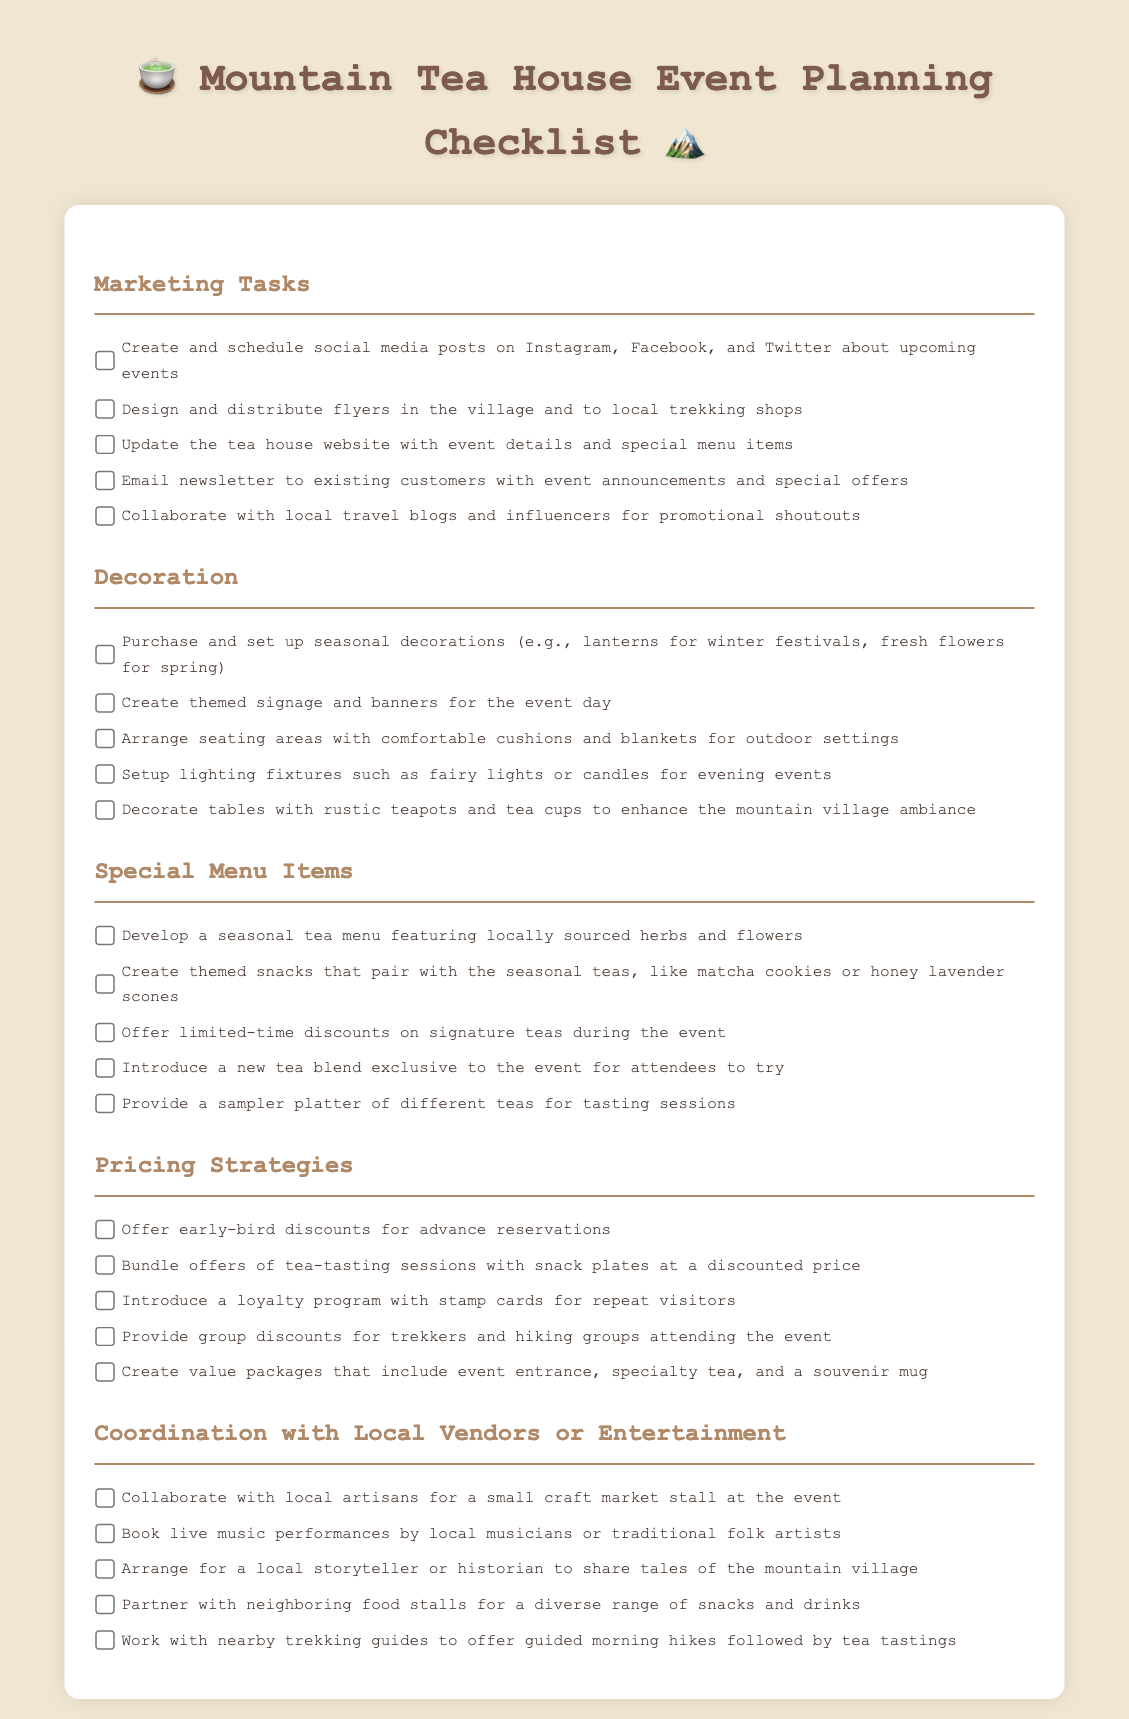What should be created and scheduled on social media? The checklist includes creating and scheduling social media posts about upcoming events.
Answer: Social media posts How many tasks are listed under Special Menu Items? The document states five tasks under the Special Menu Items section.
Answer: Five What type of discounts are mentioned for advance reservations? The pricing strategy includes offering early-bird discounts for advance reservations.
Answer: Early-bird discounts What decoration is suggested for evening events? The checklist suggests setting up lighting fixtures such as fairy lights or candles for evening events.
Answer: Fairy lights or candles Which local collaboration is proposed for the event? Collaborating with local artisans for a small craft market stall is proposed.
Answer: Local artisans What should be included in value packages? The checklist states that value packages should include entrance, specialty tea, and a souvenir mug.
Answer: Entrance, specialty tea, souvenir mug How many tasks are included in the Decoration section? There are five tasks listed under the Decoration section in the checklist.
Answer: Five Which local performance is suggested in the Coordination section? The document mentions booking live music performances by local musicians or traditional folk artists.
Answer: Live music performances What is one item recommended for the seasonal tea menu? Developing a seasonal tea menu featuring locally sourced herbs and flowers is recommended.
Answer: Locally sourced herbs and flowers 